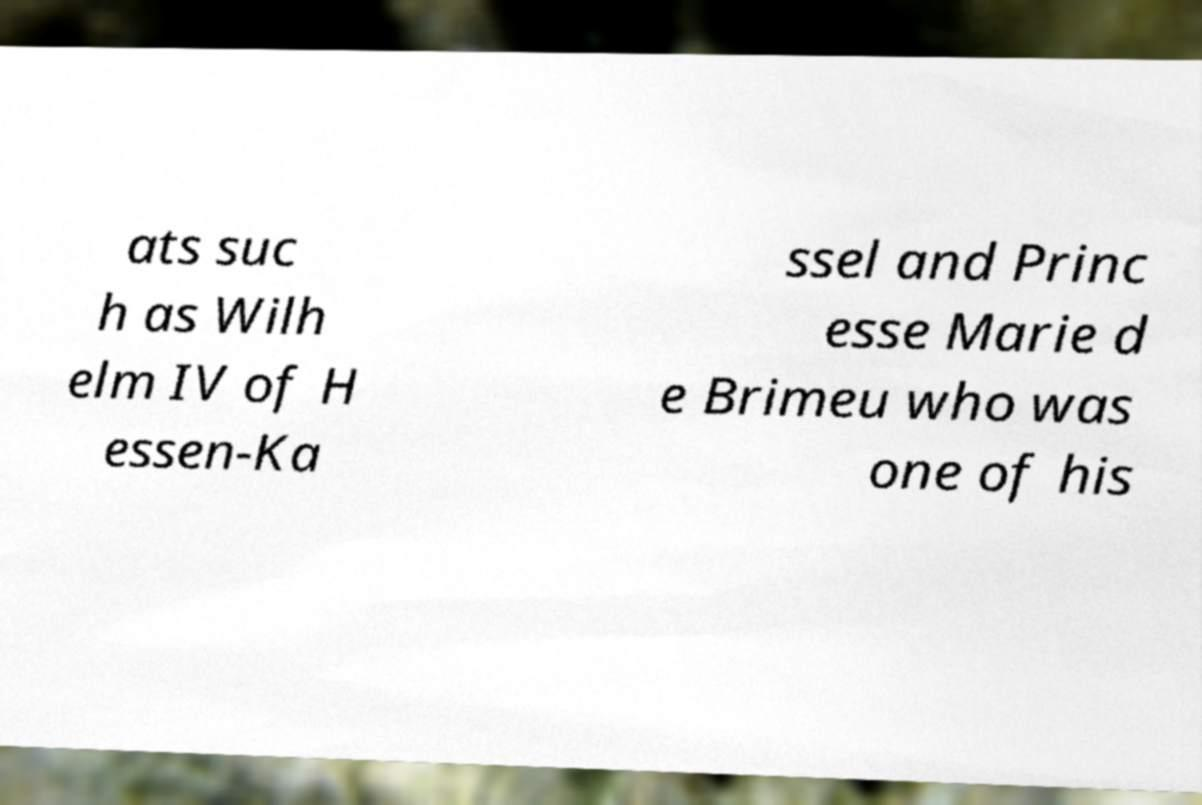Please read and relay the text visible in this image. What does it say? ats suc h as Wilh elm IV of H essen-Ka ssel and Princ esse Marie d e Brimeu who was one of his 